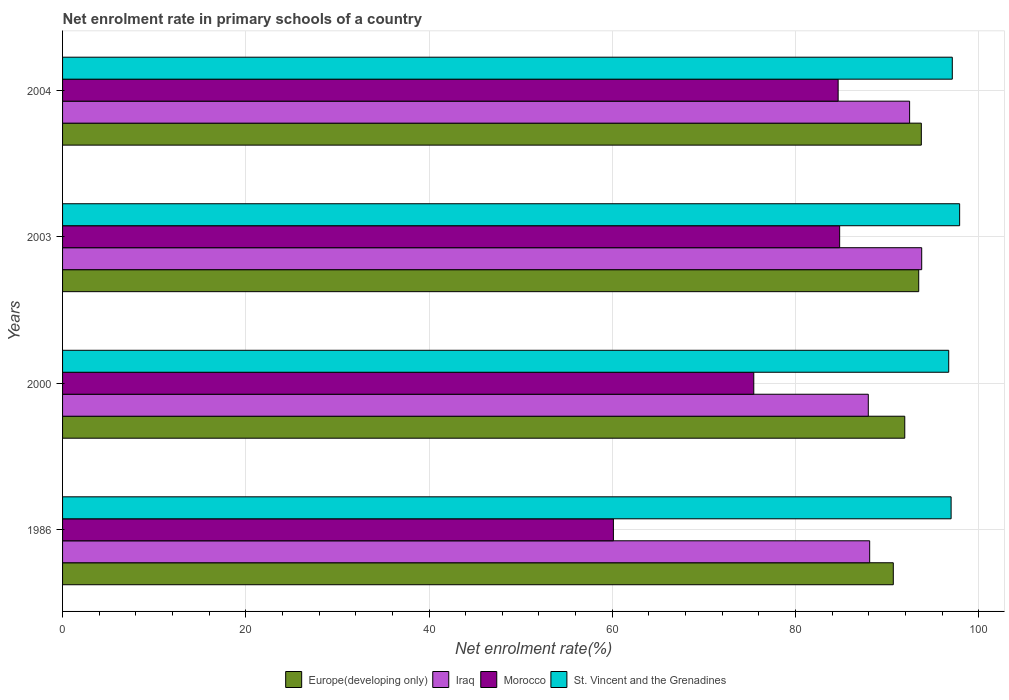How many different coloured bars are there?
Your answer should be compact. 4. Are the number of bars on each tick of the Y-axis equal?
Your answer should be very brief. Yes. How many bars are there on the 4th tick from the top?
Your response must be concise. 4. How many bars are there on the 3rd tick from the bottom?
Your response must be concise. 4. What is the label of the 1st group of bars from the top?
Provide a succinct answer. 2004. What is the net enrolment rate in primary schools in Iraq in 1986?
Ensure brevity in your answer.  88.1. Across all years, what is the maximum net enrolment rate in primary schools in Iraq?
Give a very brief answer. 93.78. Across all years, what is the minimum net enrolment rate in primary schools in Morocco?
Provide a short and direct response. 60.13. In which year was the net enrolment rate in primary schools in Morocco maximum?
Make the answer very short. 2003. What is the total net enrolment rate in primary schools in Europe(developing only) in the graph?
Your answer should be compact. 369.81. What is the difference between the net enrolment rate in primary schools in Iraq in 2003 and that in 2004?
Offer a terse response. 1.32. What is the difference between the net enrolment rate in primary schools in Morocco in 2000 and the net enrolment rate in primary schools in Iraq in 1986?
Give a very brief answer. -12.65. What is the average net enrolment rate in primary schools in Iraq per year?
Provide a short and direct response. 90.57. In the year 2003, what is the difference between the net enrolment rate in primary schools in St. Vincent and the Grenadines and net enrolment rate in primary schools in Europe(developing only)?
Your answer should be compact. 4.47. In how many years, is the net enrolment rate in primary schools in Europe(developing only) greater than 84 %?
Provide a succinct answer. 4. What is the ratio of the net enrolment rate in primary schools in Europe(developing only) in 2003 to that in 2004?
Your answer should be compact. 1. Is the net enrolment rate in primary schools in Europe(developing only) in 2000 less than that in 2003?
Provide a succinct answer. Yes. Is the difference between the net enrolment rate in primary schools in St. Vincent and the Grenadines in 1986 and 2000 greater than the difference between the net enrolment rate in primary schools in Europe(developing only) in 1986 and 2000?
Your response must be concise. Yes. What is the difference between the highest and the second highest net enrolment rate in primary schools in Europe(developing only)?
Your answer should be compact. 0.28. What is the difference between the highest and the lowest net enrolment rate in primary schools in Europe(developing only)?
Your answer should be compact. 3.06. Is it the case that in every year, the sum of the net enrolment rate in primary schools in Iraq and net enrolment rate in primary schools in Europe(developing only) is greater than the sum of net enrolment rate in primary schools in St. Vincent and the Grenadines and net enrolment rate in primary schools in Morocco?
Offer a very short reply. No. What does the 1st bar from the top in 2004 represents?
Give a very brief answer. St. Vincent and the Grenadines. What does the 2nd bar from the bottom in 1986 represents?
Your answer should be compact. Iraq. Are the values on the major ticks of X-axis written in scientific E-notation?
Your answer should be compact. No. How many legend labels are there?
Keep it short and to the point. 4. How are the legend labels stacked?
Your response must be concise. Horizontal. What is the title of the graph?
Your answer should be compact. Net enrolment rate in primary schools of a country. Does "Haiti" appear as one of the legend labels in the graph?
Your answer should be compact. No. What is the label or title of the X-axis?
Offer a very short reply. Net enrolment rate(%). What is the Net enrolment rate(%) of Europe(developing only) in 1986?
Your answer should be compact. 90.68. What is the Net enrolment rate(%) in Iraq in 1986?
Make the answer very short. 88.1. What is the Net enrolment rate(%) in Morocco in 1986?
Your answer should be very brief. 60.13. What is the Net enrolment rate(%) of St. Vincent and the Grenadines in 1986?
Provide a succinct answer. 96.99. What is the Net enrolment rate(%) in Europe(developing only) in 2000?
Give a very brief answer. 91.93. What is the Net enrolment rate(%) in Iraq in 2000?
Provide a short and direct response. 87.95. What is the Net enrolment rate(%) of Morocco in 2000?
Your answer should be very brief. 75.45. What is the Net enrolment rate(%) in St. Vincent and the Grenadines in 2000?
Give a very brief answer. 96.73. What is the Net enrolment rate(%) of Europe(developing only) in 2003?
Your answer should be compact. 93.45. What is the Net enrolment rate(%) of Iraq in 2003?
Your response must be concise. 93.78. What is the Net enrolment rate(%) in Morocco in 2003?
Provide a short and direct response. 84.83. What is the Net enrolment rate(%) in St. Vincent and the Grenadines in 2003?
Your answer should be compact. 97.92. What is the Net enrolment rate(%) in Europe(developing only) in 2004?
Offer a very short reply. 93.74. What is the Net enrolment rate(%) in Iraq in 2004?
Give a very brief answer. 92.46. What is the Net enrolment rate(%) of Morocco in 2004?
Provide a short and direct response. 84.66. What is the Net enrolment rate(%) in St. Vincent and the Grenadines in 2004?
Provide a succinct answer. 97.12. Across all years, what is the maximum Net enrolment rate(%) in Europe(developing only)?
Your answer should be very brief. 93.74. Across all years, what is the maximum Net enrolment rate(%) of Iraq?
Your answer should be compact. 93.78. Across all years, what is the maximum Net enrolment rate(%) of Morocco?
Offer a very short reply. 84.83. Across all years, what is the maximum Net enrolment rate(%) in St. Vincent and the Grenadines?
Offer a terse response. 97.92. Across all years, what is the minimum Net enrolment rate(%) in Europe(developing only)?
Your response must be concise. 90.68. Across all years, what is the minimum Net enrolment rate(%) of Iraq?
Offer a terse response. 87.95. Across all years, what is the minimum Net enrolment rate(%) in Morocco?
Ensure brevity in your answer.  60.13. Across all years, what is the minimum Net enrolment rate(%) of St. Vincent and the Grenadines?
Ensure brevity in your answer.  96.73. What is the total Net enrolment rate(%) in Europe(developing only) in the graph?
Offer a terse response. 369.81. What is the total Net enrolment rate(%) of Iraq in the graph?
Your response must be concise. 362.29. What is the total Net enrolment rate(%) of Morocco in the graph?
Make the answer very short. 305.06. What is the total Net enrolment rate(%) in St. Vincent and the Grenadines in the graph?
Offer a very short reply. 388.76. What is the difference between the Net enrolment rate(%) of Europe(developing only) in 1986 and that in 2000?
Provide a short and direct response. -1.25. What is the difference between the Net enrolment rate(%) of Iraq in 1986 and that in 2000?
Offer a terse response. 0.15. What is the difference between the Net enrolment rate(%) of Morocco in 1986 and that in 2000?
Your answer should be very brief. -15.32. What is the difference between the Net enrolment rate(%) of St. Vincent and the Grenadines in 1986 and that in 2000?
Ensure brevity in your answer.  0.26. What is the difference between the Net enrolment rate(%) in Europe(developing only) in 1986 and that in 2003?
Your response must be concise. -2.77. What is the difference between the Net enrolment rate(%) of Iraq in 1986 and that in 2003?
Provide a short and direct response. -5.68. What is the difference between the Net enrolment rate(%) in Morocco in 1986 and that in 2003?
Ensure brevity in your answer.  -24.7. What is the difference between the Net enrolment rate(%) in St. Vincent and the Grenadines in 1986 and that in 2003?
Ensure brevity in your answer.  -0.93. What is the difference between the Net enrolment rate(%) in Europe(developing only) in 1986 and that in 2004?
Your response must be concise. -3.06. What is the difference between the Net enrolment rate(%) of Iraq in 1986 and that in 2004?
Your answer should be very brief. -4.36. What is the difference between the Net enrolment rate(%) in Morocco in 1986 and that in 2004?
Your answer should be very brief. -24.53. What is the difference between the Net enrolment rate(%) of St. Vincent and the Grenadines in 1986 and that in 2004?
Provide a succinct answer. -0.13. What is the difference between the Net enrolment rate(%) in Europe(developing only) in 2000 and that in 2003?
Make the answer very short. -1.52. What is the difference between the Net enrolment rate(%) of Iraq in 2000 and that in 2003?
Make the answer very short. -5.83. What is the difference between the Net enrolment rate(%) of Morocco in 2000 and that in 2003?
Provide a succinct answer. -9.37. What is the difference between the Net enrolment rate(%) of St. Vincent and the Grenadines in 2000 and that in 2003?
Your answer should be very brief. -1.19. What is the difference between the Net enrolment rate(%) in Europe(developing only) in 2000 and that in 2004?
Offer a very short reply. -1.81. What is the difference between the Net enrolment rate(%) in Iraq in 2000 and that in 2004?
Keep it short and to the point. -4.51. What is the difference between the Net enrolment rate(%) of Morocco in 2000 and that in 2004?
Offer a very short reply. -9.21. What is the difference between the Net enrolment rate(%) in St. Vincent and the Grenadines in 2000 and that in 2004?
Offer a very short reply. -0.39. What is the difference between the Net enrolment rate(%) of Europe(developing only) in 2003 and that in 2004?
Your response must be concise. -0.28. What is the difference between the Net enrolment rate(%) of Iraq in 2003 and that in 2004?
Give a very brief answer. 1.32. What is the difference between the Net enrolment rate(%) in Morocco in 2003 and that in 2004?
Your response must be concise. 0.17. What is the difference between the Net enrolment rate(%) of St. Vincent and the Grenadines in 2003 and that in 2004?
Provide a succinct answer. 0.8. What is the difference between the Net enrolment rate(%) of Europe(developing only) in 1986 and the Net enrolment rate(%) of Iraq in 2000?
Your answer should be very brief. 2.73. What is the difference between the Net enrolment rate(%) of Europe(developing only) in 1986 and the Net enrolment rate(%) of Morocco in 2000?
Keep it short and to the point. 15.23. What is the difference between the Net enrolment rate(%) in Europe(developing only) in 1986 and the Net enrolment rate(%) in St. Vincent and the Grenadines in 2000?
Offer a very short reply. -6.05. What is the difference between the Net enrolment rate(%) of Iraq in 1986 and the Net enrolment rate(%) of Morocco in 2000?
Provide a succinct answer. 12.65. What is the difference between the Net enrolment rate(%) in Iraq in 1986 and the Net enrolment rate(%) in St. Vincent and the Grenadines in 2000?
Your answer should be very brief. -8.63. What is the difference between the Net enrolment rate(%) in Morocco in 1986 and the Net enrolment rate(%) in St. Vincent and the Grenadines in 2000?
Make the answer very short. -36.6. What is the difference between the Net enrolment rate(%) of Europe(developing only) in 1986 and the Net enrolment rate(%) of Iraq in 2003?
Your answer should be compact. -3.1. What is the difference between the Net enrolment rate(%) of Europe(developing only) in 1986 and the Net enrolment rate(%) of Morocco in 2003?
Make the answer very short. 5.86. What is the difference between the Net enrolment rate(%) in Europe(developing only) in 1986 and the Net enrolment rate(%) in St. Vincent and the Grenadines in 2003?
Ensure brevity in your answer.  -7.24. What is the difference between the Net enrolment rate(%) of Iraq in 1986 and the Net enrolment rate(%) of Morocco in 2003?
Provide a short and direct response. 3.28. What is the difference between the Net enrolment rate(%) in Iraq in 1986 and the Net enrolment rate(%) in St. Vincent and the Grenadines in 2003?
Provide a succinct answer. -9.82. What is the difference between the Net enrolment rate(%) of Morocco in 1986 and the Net enrolment rate(%) of St. Vincent and the Grenadines in 2003?
Ensure brevity in your answer.  -37.79. What is the difference between the Net enrolment rate(%) of Europe(developing only) in 1986 and the Net enrolment rate(%) of Iraq in 2004?
Give a very brief answer. -1.78. What is the difference between the Net enrolment rate(%) in Europe(developing only) in 1986 and the Net enrolment rate(%) in Morocco in 2004?
Keep it short and to the point. 6.02. What is the difference between the Net enrolment rate(%) in Europe(developing only) in 1986 and the Net enrolment rate(%) in St. Vincent and the Grenadines in 2004?
Provide a succinct answer. -6.44. What is the difference between the Net enrolment rate(%) in Iraq in 1986 and the Net enrolment rate(%) in Morocco in 2004?
Your answer should be compact. 3.44. What is the difference between the Net enrolment rate(%) in Iraq in 1986 and the Net enrolment rate(%) in St. Vincent and the Grenadines in 2004?
Provide a succinct answer. -9.02. What is the difference between the Net enrolment rate(%) of Morocco in 1986 and the Net enrolment rate(%) of St. Vincent and the Grenadines in 2004?
Provide a succinct answer. -36.99. What is the difference between the Net enrolment rate(%) in Europe(developing only) in 2000 and the Net enrolment rate(%) in Iraq in 2003?
Give a very brief answer. -1.85. What is the difference between the Net enrolment rate(%) in Europe(developing only) in 2000 and the Net enrolment rate(%) in Morocco in 2003?
Your answer should be very brief. 7.11. What is the difference between the Net enrolment rate(%) in Europe(developing only) in 2000 and the Net enrolment rate(%) in St. Vincent and the Grenadines in 2003?
Keep it short and to the point. -5.99. What is the difference between the Net enrolment rate(%) in Iraq in 2000 and the Net enrolment rate(%) in Morocco in 2003?
Keep it short and to the point. 3.13. What is the difference between the Net enrolment rate(%) of Iraq in 2000 and the Net enrolment rate(%) of St. Vincent and the Grenadines in 2003?
Make the answer very short. -9.97. What is the difference between the Net enrolment rate(%) in Morocco in 2000 and the Net enrolment rate(%) in St. Vincent and the Grenadines in 2003?
Ensure brevity in your answer.  -22.47. What is the difference between the Net enrolment rate(%) of Europe(developing only) in 2000 and the Net enrolment rate(%) of Iraq in 2004?
Your response must be concise. -0.53. What is the difference between the Net enrolment rate(%) of Europe(developing only) in 2000 and the Net enrolment rate(%) of Morocco in 2004?
Keep it short and to the point. 7.27. What is the difference between the Net enrolment rate(%) in Europe(developing only) in 2000 and the Net enrolment rate(%) in St. Vincent and the Grenadines in 2004?
Provide a short and direct response. -5.19. What is the difference between the Net enrolment rate(%) in Iraq in 2000 and the Net enrolment rate(%) in Morocco in 2004?
Offer a terse response. 3.29. What is the difference between the Net enrolment rate(%) in Iraq in 2000 and the Net enrolment rate(%) in St. Vincent and the Grenadines in 2004?
Give a very brief answer. -9.17. What is the difference between the Net enrolment rate(%) in Morocco in 2000 and the Net enrolment rate(%) in St. Vincent and the Grenadines in 2004?
Your answer should be very brief. -21.67. What is the difference between the Net enrolment rate(%) in Europe(developing only) in 2003 and the Net enrolment rate(%) in Morocco in 2004?
Give a very brief answer. 8.8. What is the difference between the Net enrolment rate(%) in Europe(developing only) in 2003 and the Net enrolment rate(%) in St. Vincent and the Grenadines in 2004?
Provide a short and direct response. -3.67. What is the difference between the Net enrolment rate(%) in Iraq in 2003 and the Net enrolment rate(%) in Morocco in 2004?
Give a very brief answer. 9.12. What is the difference between the Net enrolment rate(%) of Iraq in 2003 and the Net enrolment rate(%) of St. Vincent and the Grenadines in 2004?
Keep it short and to the point. -3.34. What is the difference between the Net enrolment rate(%) in Morocco in 2003 and the Net enrolment rate(%) in St. Vincent and the Grenadines in 2004?
Your answer should be compact. -12.3. What is the average Net enrolment rate(%) in Europe(developing only) per year?
Offer a very short reply. 92.45. What is the average Net enrolment rate(%) in Iraq per year?
Provide a succinct answer. 90.57. What is the average Net enrolment rate(%) of Morocco per year?
Your answer should be very brief. 76.27. What is the average Net enrolment rate(%) in St. Vincent and the Grenadines per year?
Provide a short and direct response. 97.19. In the year 1986, what is the difference between the Net enrolment rate(%) of Europe(developing only) and Net enrolment rate(%) of Iraq?
Ensure brevity in your answer.  2.58. In the year 1986, what is the difference between the Net enrolment rate(%) in Europe(developing only) and Net enrolment rate(%) in Morocco?
Make the answer very short. 30.55. In the year 1986, what is the difference between the Net enrolment rate(%) in Europe(developing only) and Net enrolment rate(%) in St. Vincent and the Grenadines?
Your answer should be compact. -6.31. In the year 1986, what is the difference between the Net enrolment rate(%) of Iraq and Net enrolment rate(%) of Morocco?
Your response must be concise. 27.97. In the year 1986, what is the difference between the Net enrolment rate(%) of Iraq and Net enrolment rate(%) of St. Vincent and the Grenadines?
Provide a succinct answer. -8.89. In the year 1986, what is the difference between the Net enrolment rate(%) in Morocco and Net enrolment rate(%) in St. Vincent and the Grenadines?
Ensure brevity in your answer.  -36.86. In the year 2000, what is the difference between the Net enrolment rate(%) in Europe(developing only) and Net enrolment rate(%) in Iraq?
Give a very brief answer. 3.98. In the year 2000, what is the difference between the Net enrolment rate(%) of Europe(developing only) and Net enrolment rate(%) of Morocco?
Provide a succinct answer. 16.48. In the year 2000, what is the difference between the Net enrolment rate(%) of Europe(developing only) and Net enrolment rate(%) of St. Vincent and the Grenadines?
Ensure brevity in your answer.  -4.8. In the year 2000, what is the difference between the Net enrolment rate(%) of Iraq and Net enrolment rate(%) of Morocco?
Your answer should be very brief. 12.5. In the year 2000, what is the difference between the Net enrolment rate(%) in Iraq and Net enrolment rate(%) in St. Vincent and the Grenadines?
Keep it short and to the point. -8.78. In the year 2000, what is the difference between the Net enrolment rate(%) in Morocco and Net enrolment rate(%) in St. Vincent and the Grenadines?
Offer a very short reply. -21.28. In the year 2003, what is the difference between the Net enrolment rate(%) in Europe(developing only) and Net enrolment rate(%) in Iraq?
Your response must be concise. -0.33. In the year 2003, what is the difference between the Net enrolment rate(%) of Europe(developing only) and Net enrolment rate(%) of Morocco?
Your answer should be compact. 8.63. In the year 2003, what is the difference between the Net enrolment rate(%) in Europe(developing only) and Net enrolment rate(%) in St. Vincent and the Grenadines?
Ensure brevity in your answer.  -4.47. In the year 2003, what is the difference between the Net enrolment rate(%) of Iraq and Net enrolment rate(%) of Morocco?
Ensure brevity in your answer.  8.96. In the year 2003, what is the difference between the Net enrolment rate(%) in Iraq and Net enrolment rate(%) in St. Vincent and the Grenadines?
Offer a terse response. -4.14. In the year 2003, what is the difference between the Net enrolment rate(%) of Morocco and Net enrolment rate(%) of St. Vincent and the Grenadines?
Your answer should be very brief. -13.1. In the year 2004, what is the difference between the Net enrolment rate(%) of Europe(developing only) and Net enrolment rate(%) of Iraq?
Offer a terse response. 1.28. In the year 2004, what is the difference between the Net enrolment rate(%) of Europe(developing only) and Net enrolment rate(%) of Morocco?
Keep it short and to the point. 9.08. In the year 2004, what is the difference between the Net enrolment rate(%) in Europe(developing only) and Net enrolment rate(%) in St. Vincent and the Grenadines?
Make the answer very short. -3.38. In the year 2004, what is the difference between the Net enrolment rate(%) in Iraq and Net enrolment rate(%) in Morocco?
Offer a very short reply. 7.8. In the year 2004, what is the difference between the Net enrolment rate(%) in Iraq and Net enrolment rate(%) in St. Vincent and the Grenadines?
Your response must be concise. -4.66. In the year 2004, what is the difference between the Net enrolment rate(%) of Morocco and Net enrolment rate(%) of St. Vincent and the Grenadines?
Your response must be concise. -12.46. What is the ratio of the Net enrolment rate(%) in Europe(developing only) in 1986 to that in 2000?
Ensure brevity in your answer.  0.99. What is the ratio of the Net enrolment rate(%) in Morocco in 1986 to that in 2000?
Your answer should be very brief. 0.8. What is the ratio of the Net enrolment rate(%) of Europe(developing only) in 1986 to that in 2003?
Your answer should be compact. 0.97. What is the ratio of the Net enrolment rate(%) in Iraq in 1986 to that in 2003?
Offer a very short reply. 0.94. What is the ratio of the Net enrolment rate(%) in Morocco in 1986 to that in 2003?
Provide a short and direct response. 0.71. What is the ratio of the Net enrolment rate(%) of Europe(developing only) in 1986 to that in 2004?
Make the answer very short. 0.97. What is the ratio of the Net enrolment rate(%) of Iraq in 1986 to that in 2004?
Make the answer very short. 0.95. What is the ratio of the Net enrolment rate(%) of Morocco in 1986 to that in 2004?
Offer a terse response. 0.71. What is the ratio of the Net enrolment rate(%) in St. Vincent and the Grenadines in 1986 to that in 2004?
Provide a succinct answer. 1. What is the ratio of the Net enrolment rate(%) of Europe(developing only) in 2000 to that in 2003?
Provide a short and direct response. 0.98. What is the ratio of the Net enrolment rate(%) in Iraq in 2000 to that in 2003?
Make the answer very short. 0.94. What is the ratio of the Net enrolment rate(%) in Morocco in 2000 to that in 2003?
Give a very brief answer. 0.89. What is the ratio of the Net enrolment rate(%) of Europe(developing only) in 2000 to that in 2004?
Ensure brevity in your answer.  0.98. What is the ratio of the Net enrolment rate(%) of Iraq in 2000 to that in 2004?
Your answer should be very brief. 0.95. What is the ratio of the Net enrolment rate(%) of Morocco in 2000 to that in 2004?
Your answer should be compact. 0.89. What is the ratio of the Net enrolment rate(%) of St. Vincent and the Grenadines in 2000 to that in 2004?
Provide a short and direct response. 1. What is the ratio of the Net enrolment rate(%) in Europe(developing only) in 2003 to that in 2004?
Your answer should be very brief. 1. What is the ratio of the Net enrolment rate(%) of Iraq in 2003 to that in 2004?
Give a very brief answer. 1.01. What is the ratio of the Net enrolment rate(%) of St. Vincent and the Grenadines in 2003 to that in 2004?
Offer a terse response. 1.01. What is the difference between the highest and the second highest Net enrolment rate(%) of Europe(developing only)?
Your answer should be very brief. 0.28. What is the difference between the highest and the second highest Net enrolment rate(%) in Iraq?
Ensure brevity in your answer.  1.32. What is the difference between the highest and the second highest Net enrolment rate(%) of Morocco?
Keep it short and to the point. 0.17. What is the difference between the highest and the second highest Net enrolment rate(%) in St. Vincent and the Grenadines?
Provide a succinct answer. 0.8. What is the difference between the highest and the lowest Net enrolment rate(%) of Europe(developing only)?
Make the answer very short. 3.06. What is the difference between the highest and the lowest Net enrolment rate(%) of Iraq?
Make the answer very short. 5.83. What is the difference between the highest and the lowest Net enrolment rate(%) of Morocco?
Make the answer very short. 24.7. What is the difference between the highest and the lowest Net enrolment rate(%) of St. Vincent and the Grenadines?
Your answer should be very brief. 1.19. 